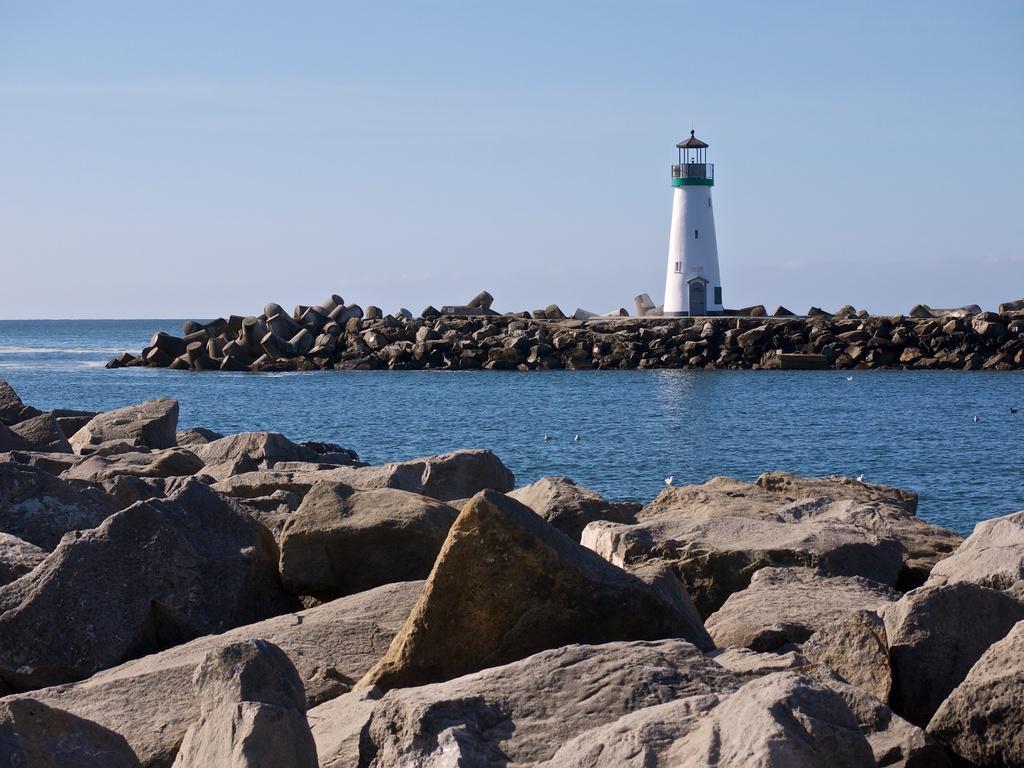Describe this image in one or two sentences. In the foreground of the picture there are stones. In the center of the picture there are stones, lighthouse and water. Sky is clear and it is sunny. 